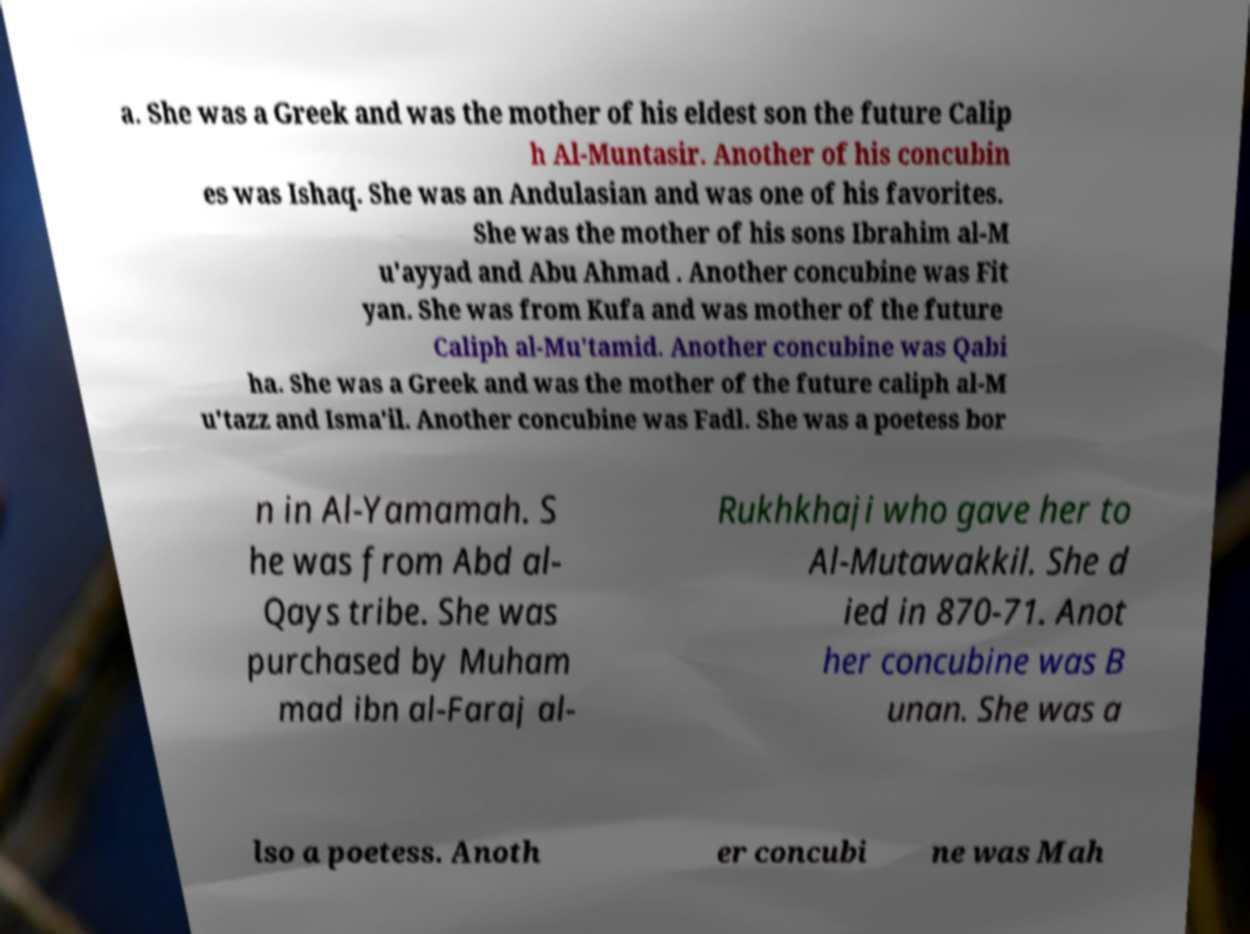Please read and relay the text visible in this image. What does it say? a. She was a Greek and was the mother of his eldest son the future Calip h Al-Muntasir. Another of his concubin es was Ishaq. She was an Andulasian and was one of his favorites. She was the mother of his sons Ibrahim al-M u'ayyad and Abu Ahmad . Another concubine was Fit yan. She was from Kufa and was mother of the future Caliph al-Mu'tamid. Another concubine was Qabi ha. She was a Greek and was the mother of the future caliph al-M u'tazz and Isma'il. Another concubine was Fadl. She was a poetess bor n in Al-Yamamah. S he was from Abd al- Qays tribe. She was purchased by Muham mad ibn al-Faraj al- Rukhkhaji who gave her to Al-Mutawakkil. She d ied in 870-71. Anot her concubine was B unan. She was a lso a poetess. Anoth er concubi ne was Mah 